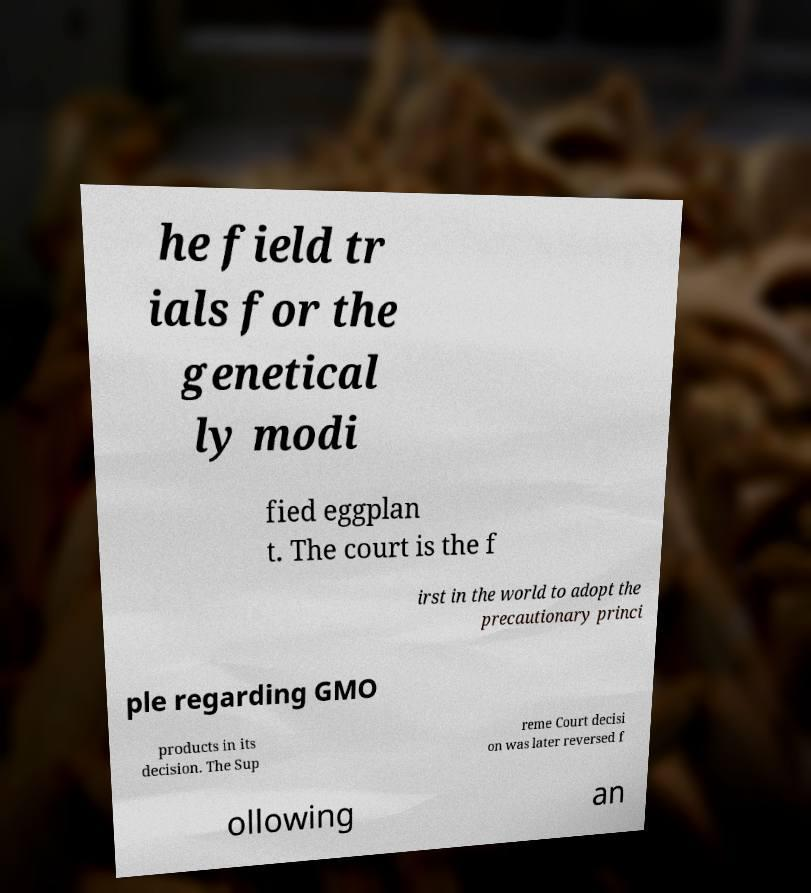There's text embedded in this image that I need extracted. Can you transcribe it verbatim? he field tr ials for the genetical ly modi fied eggplan t. The court is the f irst in the world to adopt the precautionary princi ple regarding GMO products in its decision. The Sup reme Court decisi on was later reversed f ollowing an 